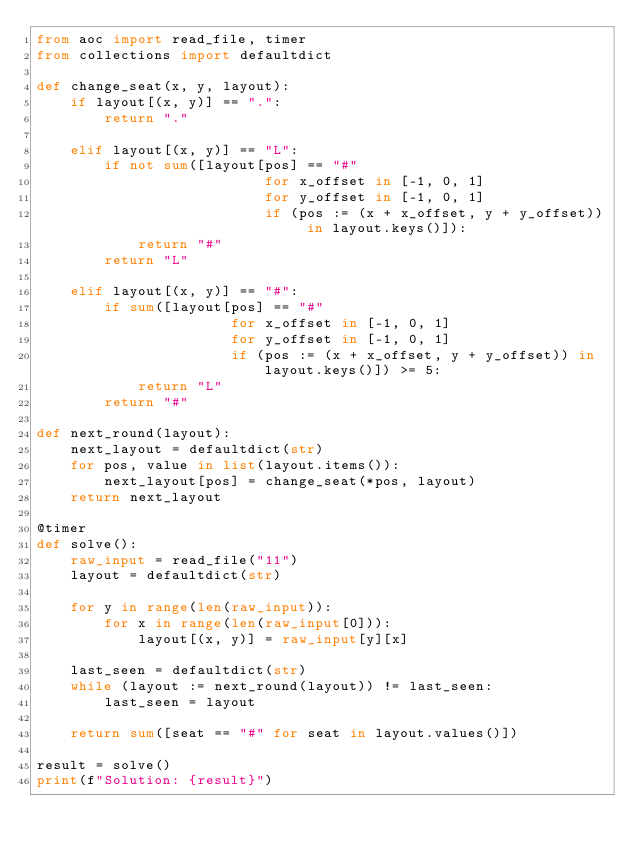Convert code to text. <code><loc_0><loc_0><loc_500><loc_500><_Python_>from aoc import read_file, timer
from collections import defaultdict

def change_seat(x, y, layout):
    if layout[(x, y)] == ".":
        return "."
    
    elif layout[(x, y)] == "L":
        if not sum([layout[pos] == "#"
                           for x_offset in [-1, 0, 1]
                           for y_offset in [-1, 0, 1]
                           if (pos := (x + x_offset, y + y_offset)) in layout.keys()]):
            return "#"
        return "L"
    
    elif layout[(x, y)] == "#":
        if sum([layout[pos] == "#"
                       for x_offset in [-1, 0, 1]
                       for y_offset in [-1, 0, 1]
                       if (pos := (x + x_offset, y + y_offset)) in layout.keys()]) >= 5:
            return "L"
        return "#"

def next_round(layout):
    next_layout = defaultdict(str)
    for pos, value in list(layout.items()):
        next_layout[pos] = change_seat(*pos, layout)
    return next_layout

@timer
def solve():
    raw_input = read_file("11")
    layout = defaultdict(str)
    
    for y in range(len(raw_input)):
        for x in range(len(raw_input[0])):
            layout[(x, y)] = raw_input[y][x]
    
    last_seen = defaultdict(str)
    while (layout := next_round(layout)) != last_seen:
        last_seen = layout
    
    return sum([seat == "#" for seat in layout.values()])

result = solve()
print(f"Solution: {result}")</code> 